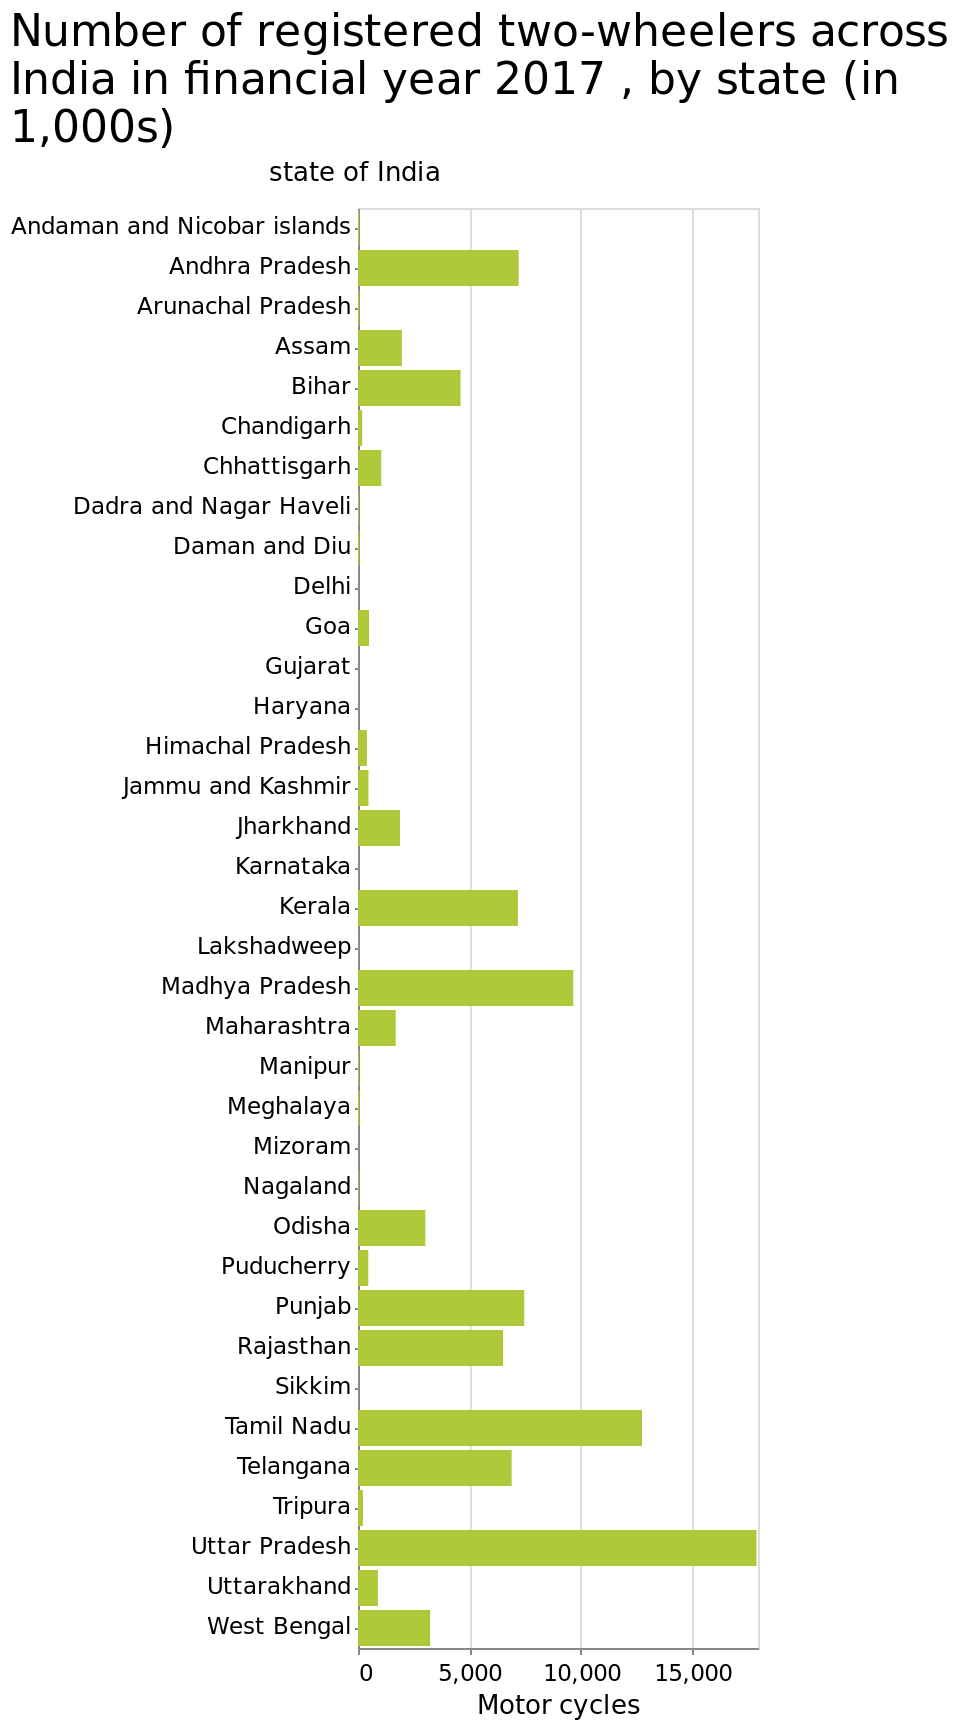<image>
What does the x-axis represent in the bar plot?  The x-axis represents the different states of India. What does the figure reveal about the scale of registered motor cycles in 2017? The figure reveals that there is a significant difference between the numbers of registered motor cycles in different cities in 2017. 